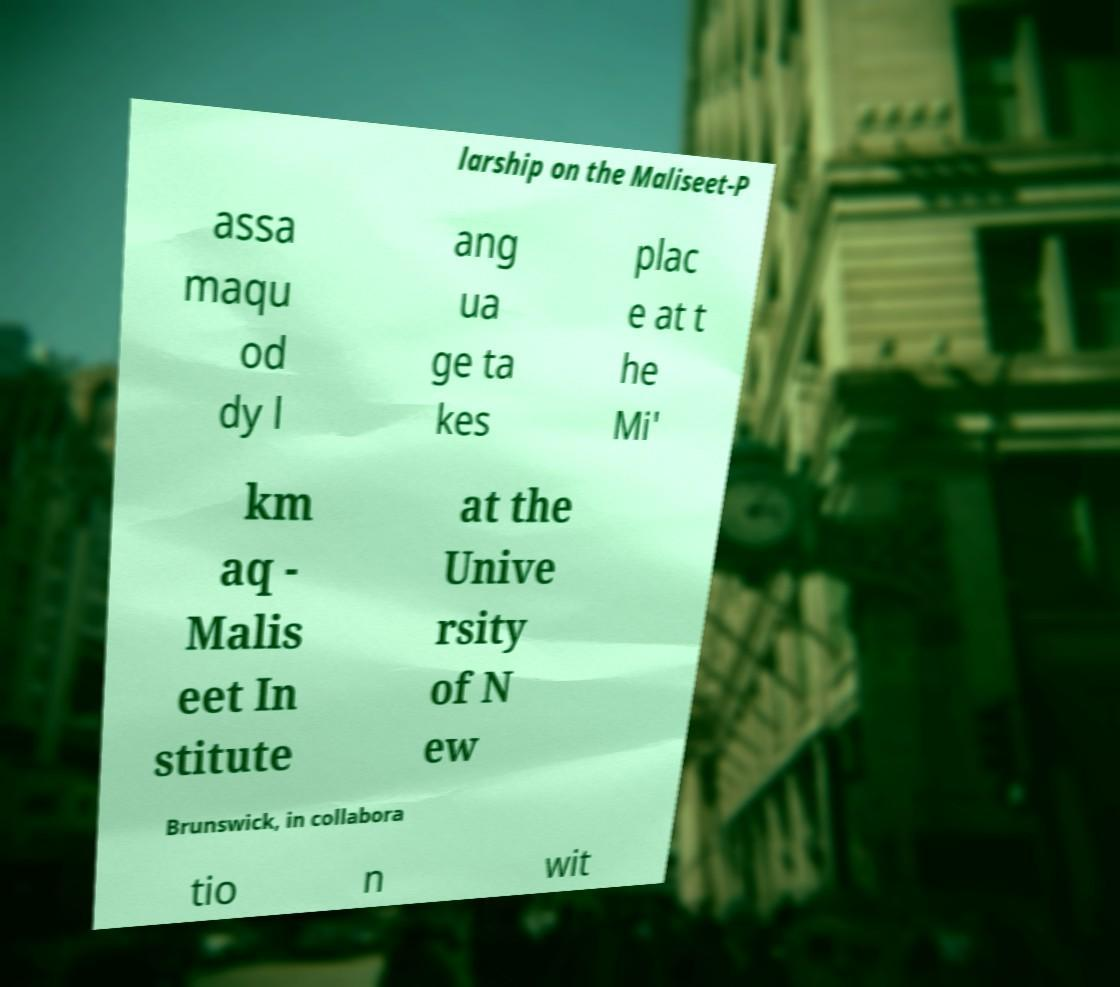There's text embedded in this image that I need extracted. Can you transcribe it verbatim? larship on the Maliseet-P assa maqu od dy l ang ua ge ta kes plac e at t he Mi' km aq - Malis eet In stitute at the Unive rsity of N ew Brunswick, in collabora tio n wit 